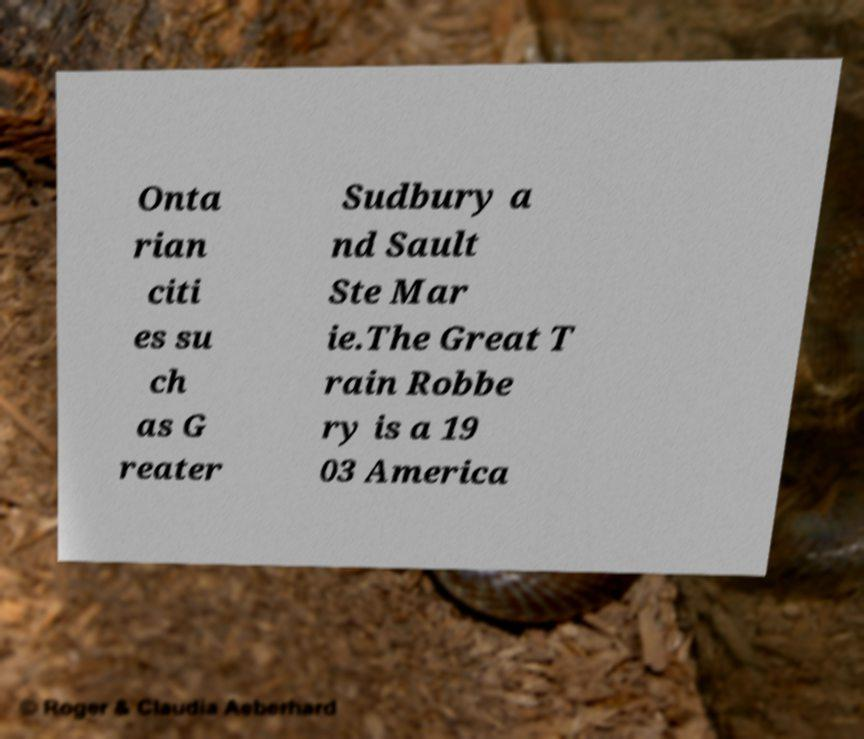Please read and relay the text visible in this image. What does it say? Onta rian citi es su ch as G reater Sudbury a nd Sault Ste Mar ie.The Great T rain Robbe ry is a 19 03 America 